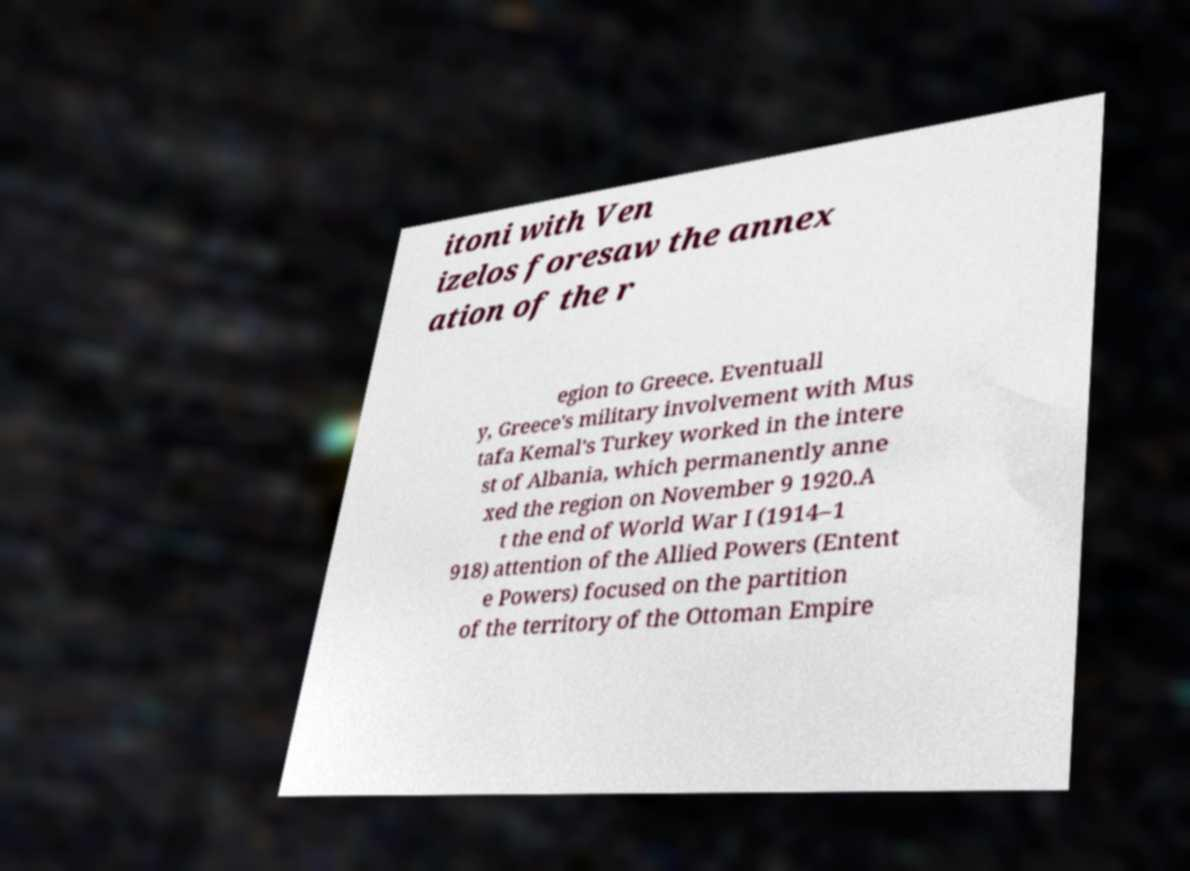Could you extract and type out the text from this image? itoni with Ven izelos foresaw the annex ation of the r egion to Greece. Eventuall y, Greece's military involvement with Mus tafa Kemal's Turkey worked in the intere st of Albania, which permanently anne xed the region on November 9 1920.A t the end of World War I (1914–1 918) attention of the Allied Powers (Entent e Powers) focused on the partition of the territory of the Ottoman Empire 